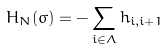Convert formula to latex. <formula><loc_0><loc_0><loc_500><loc_500>H _ { N } ( \sigma ) = - \sum _ { i \in \Lambda } h _ { i , i + 1 }</formula> 